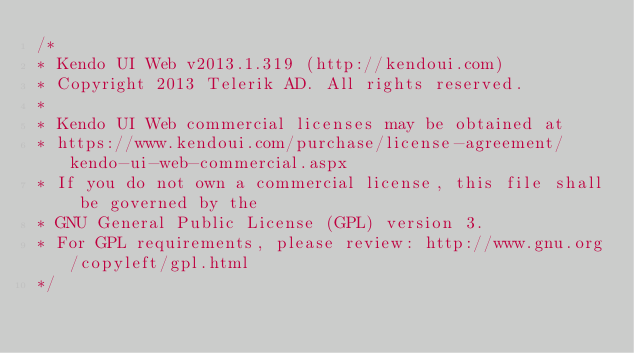Convert code to text. <code><loc_0><loc_0><loc_500><loc_500><_CSS_>/*
* Kendo UI Web v2013.1.319 (http://kendoui.com)
* Copyright 2013 Telerik AD. All rights reserved.
*
* Kendo UI Web commercial licenses may be obtained at
* https://www.kendoui.com/purchase/license-agreement/kendo-ui-web-commercial.aspx
* If you do not own a commercial license, this file shall be governed by the
* GNU General Public License (GPL) version 3.
* For GPL requirements, please review: http://www.gnu.org/copyleft/gpl.html
*/</code> 